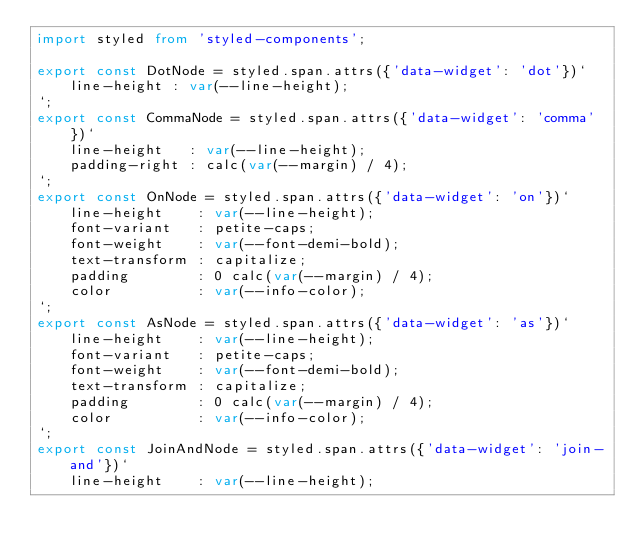Convert code to text. <code><loc_0><loc_0><loc_500><loc_500><_TypeScript_>import styled from 'styled-components';

export const DotNode = styled.span.attrs({'data-widget': 'dot'})`
	line-height : var(--line-height);
`;
export const CommaNode = styled.span.attrs({'data-widget': 'comma'})`
	line-height   : var(--line-height);
	padding-right : calc(var(--margin) / 4);
`;
export const OnNode = styled.span.attrs({'data-widget': 'on'})`
	line-height    : var(--line-height);
	font-variant   : petite-caps;
	font-weight    : var(--font-demi-bold);
	text-transform : capitalize;
	padding        : 0 calc(var(--margin) / 4);
	color          : var(--info-color);
`;
export const AsNode = styled.span.attrs({'data-widget': 'as'})`
	line-height    : var(--line-height);
	font-variant   : petite-caps;
	font-weight    : var(--font-demi-bold);
	text-transform : capitalize;
	padding        : 0 calc(var(--margin) / 4);
	color          : var(--info-color);
`;
export const JoinAndNode = styled.span.attrs({'data-widget': 'join-and'})`
	line-height    : var(--line-height);</code> 